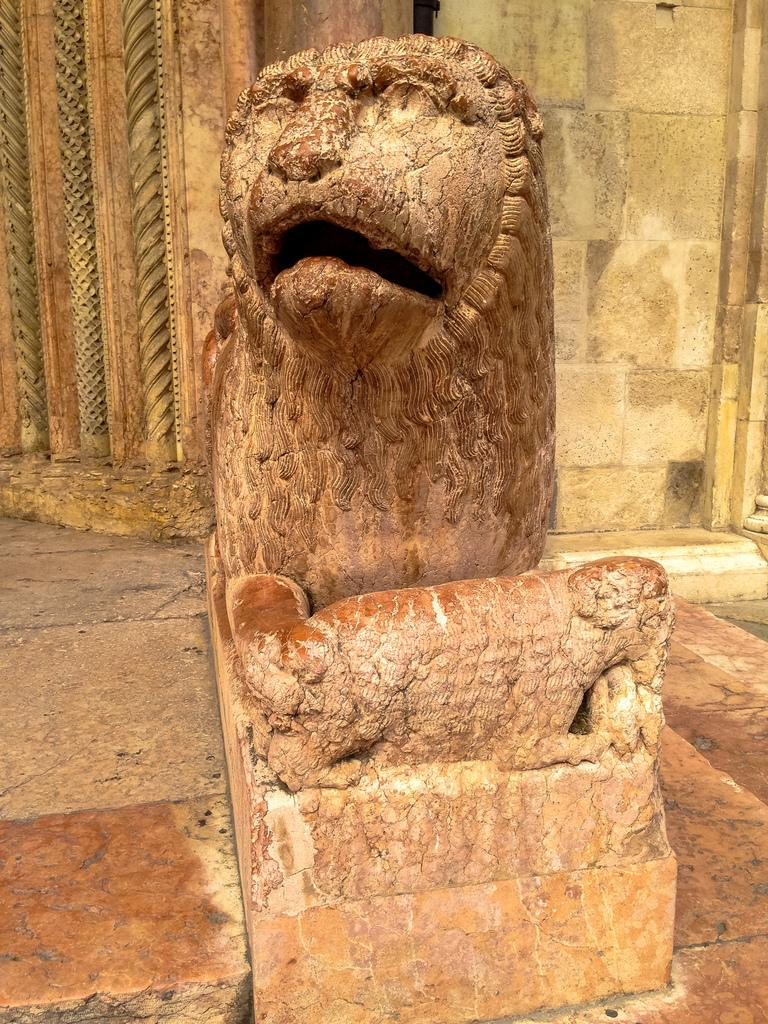What is the main subject in the center of the image? There is a statue in the center of the image. Where is the statue located? The statue is on the ground. What else can be seen in the image besides the statue? There is a wall visible in the image. How does the statue's partner feel about the pollution in the image? There is no partner mentioned in the image, and no pollution is visible. 